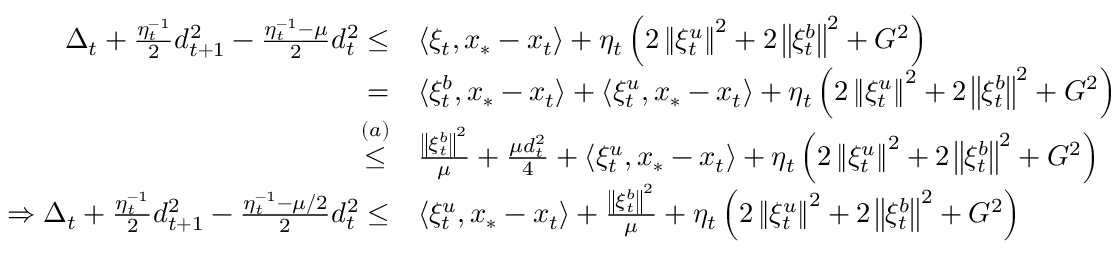<formula> <loc_0><loc_0><loc_500><loc_500>\begin{array} { r l } { \Delta _ { t } + \frac { \eta _ { t } ^ { - 1 } } { 2 } d _ { t + 1 } ^ { 2 } - \frac { \eta _ { t } ^ { - 1 } - \mu } { 2 } d _ { t } ^ { 2 } \leq } & { \langle \xi _ { t } , x _ { * } - x _ { t } \rangle + \eta _ { t } \left ( 2 \left \| \xi _ { t } ^ { u } \right \| ^ { 2 } + 2 \left \| \xi _ { t } ^ { b } \right \| ^ { 2 } + G ^ { 2 } \right ) } \\ { = } & { \langle \xi _ { t } ^ { b } , x _ { * } - x _ { t } \rangle + \langle \xi _ { t } ^ { u } , x _ { * } - x _ { t } \rangle + \eta _ { t } \left ( 2 \left \| \xi _ { t } ^ { u } \right \| ^ { 2 } + 2 \left \| \xi _ { t } ^ { b } \right \| ^ { 2 } + G ^ { 2 } \right ) } \\ { \overset { ( a ) } { \leq } } & { \frac { \left \| \xi _ { t } ^ { b } \right \| ^ { 2 } } { \mu } + \frac { \mu d _ { t } ^ { 2 } } { 4 } + \langle \xi _ { t } ^ { u } , x _ { * } - x _ { t } \rangle + \eta _ { t } \left ( 2 \left \| \xi _ { t } ^ { u } \right \| ^ { 2 } + 2 \left \| \xi _ { t } ^ { b } \right \| ^ { 2 } + G ^ { 2 } \right ) } \\ { \Rightarrow \Delta _ { t } + \frac { \eta _ { t } ^ { - 1 } } { 2 } d _ { t + 1 } ^ { 2 } - \frac { \eta _ { t } ^ { - 1 } - \mu / 2 } { 2 } d _ { t } ^ { 2 } \leq } & { \langle \xi _ { t } ^ { u } , x _ { * } - x _ { t } \rangle + \frac { \left \| \xi _ { t } ^ { b } \right \| ^ { 2 } } { \mu } + \eta _ { t } \left ( 2 \left \| \xi _ { t } ^ { u } \right \| ^ { 2 } + 2 \left \| \xi _ { t } ^ { b } \right \| ^ { 2 } + G ^ { 2 } \right ) } \end{array}</formula> 